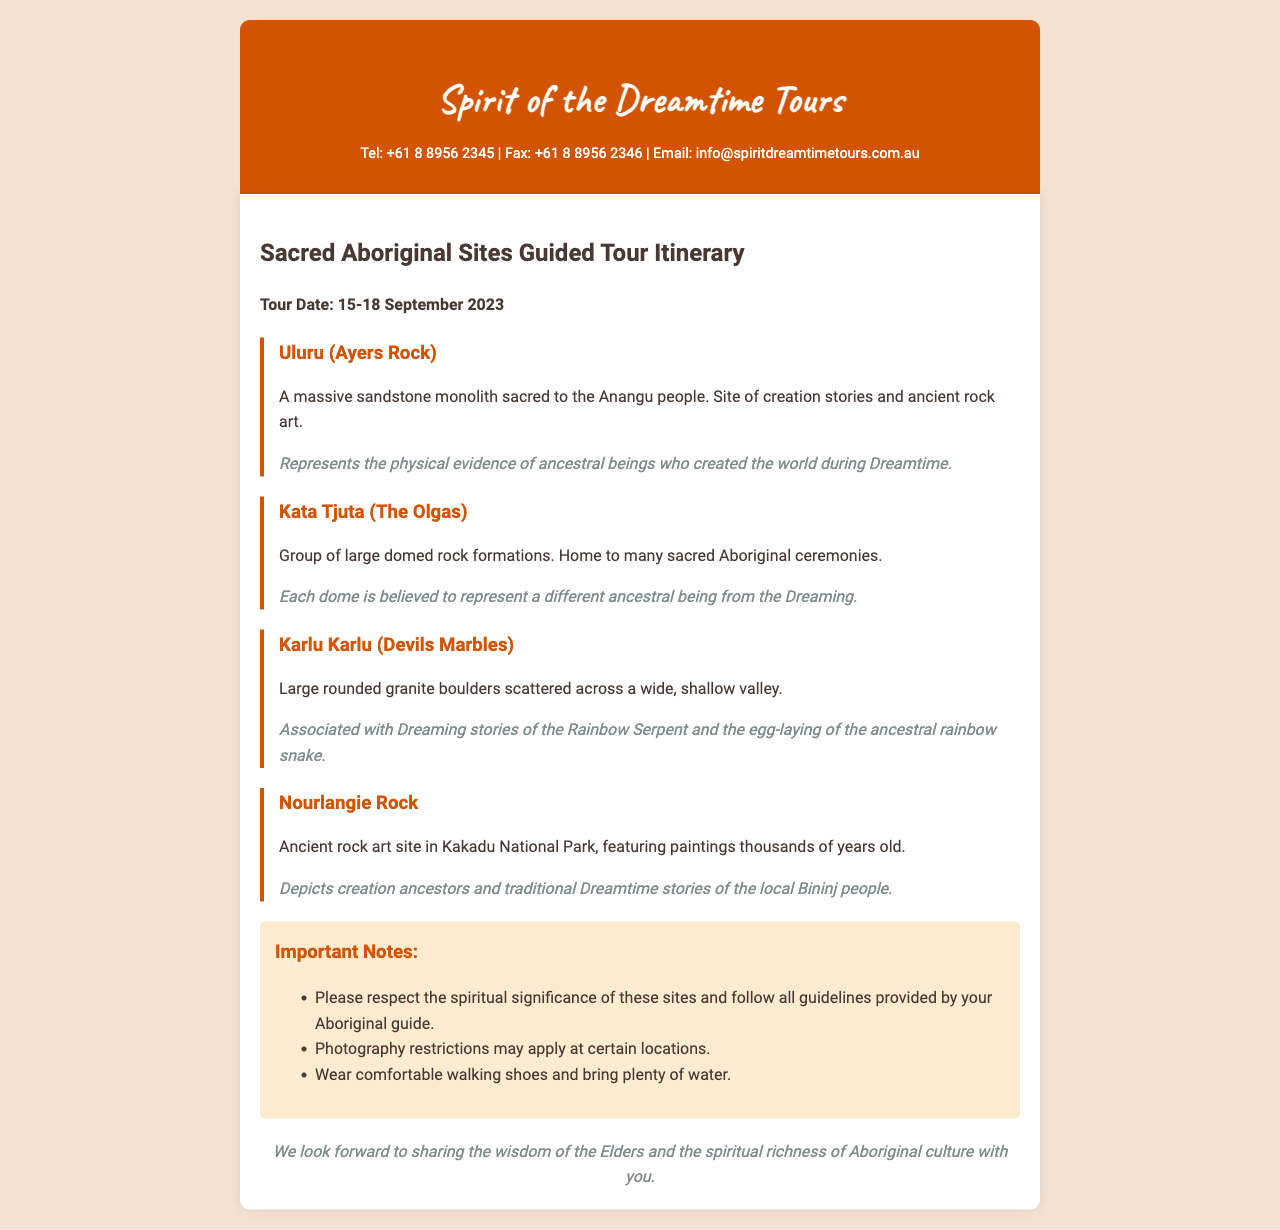What is the name of the tour company? The name of the tour company is stated at the top of the document under the title.
Answer: Spirit of the Dreamtime Tours What are the contact methods listed? The document includes various contact methods such as telephone, fax, and email.
Answer: Tel, Fax, Email What is the tour date? The specific date for the guided tour is mentioned in the itinerary section.
Answer: 15-18 September 2023 How many locations are listed in the itinerary? The document outlines four specific locations as part of the tour itinerary.
Answer: Four What does Uluru represent? The spiritual significance of Uluru is provided in the description section.
Answer: The physical evidence of ancestral beings who created the world during Dreamtime Which location is associated with the Rainbow Serpent? The document describes the spiritual significance of Karlu Karlu linked to specific Dreaming stories.
Answer: Karlu Karlu What is a key guideline for participants? The document lists important notes regarding behavior and preparation for the tour.
Answer: Respect the spiritual significance Is photography allowed everywhere on the tour? The notes section mentions specific conditions regarding photography restrictions.
Answer: No 